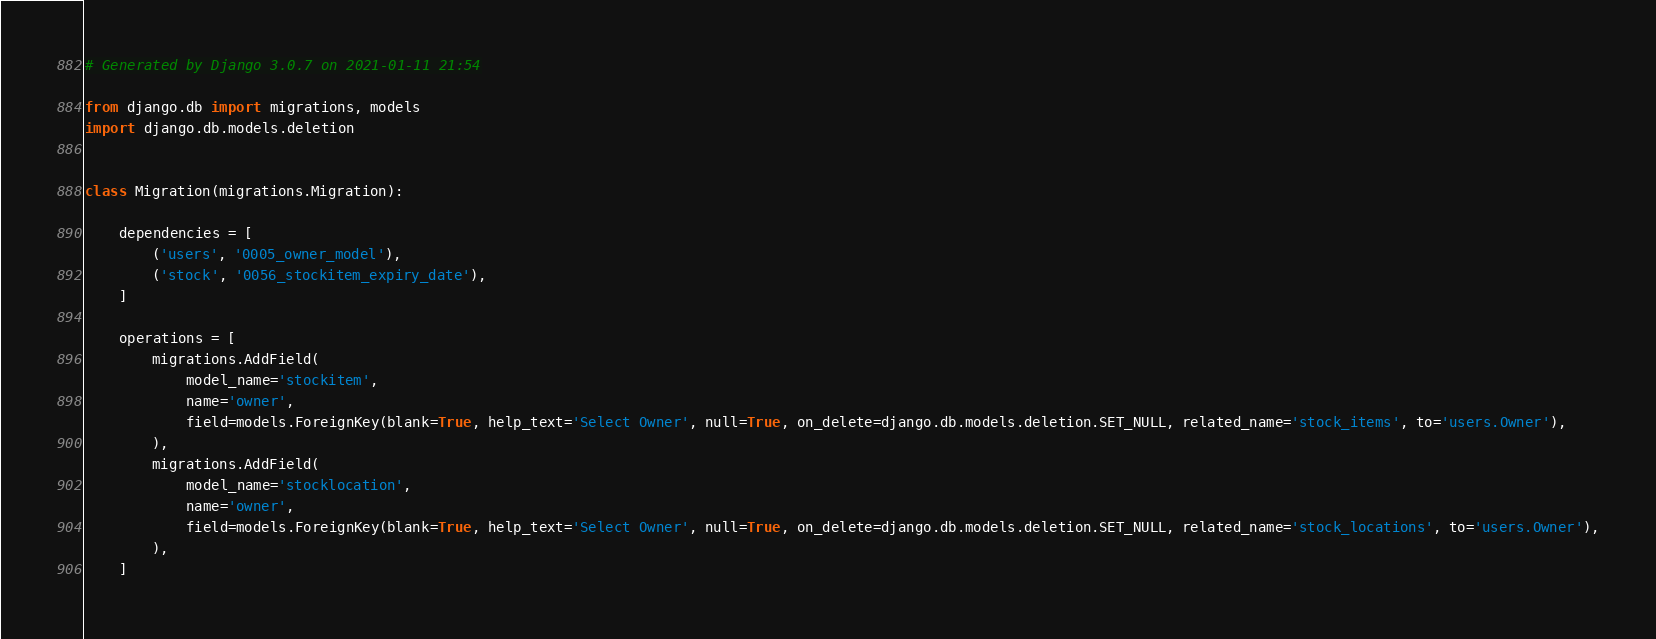Convert code to text. <code><loc_0><loc_0><loc_500><loc_500><_Python_># Generated by Django 3.0.7 on 2021-01-11 21:54

from django.db import migrations, models
import django.db.models.deletion


class Migration(migrations.Migration):

    dependencies = [
        ('users', '0005_owner_model'),
        ('stock', '0056_stockitem_expiry_date'),
    ]

    operations = [
        migrations.AddField(
            model_name='stockitem',
            name='owner',
            field=models.ForeignKey(blank=True, help_text='Select Owner', null=True, on_delete=django.db.models.deletion.SET_NULL, related_name='stock_items', to='users.Owner'),
        ),
        migrations.AddField(
            model_name='stocklocation',
            name='owner',
            field=models.ForeignKey(blank=True, help_text='Select Owner', null=True, on_delete=django.db.models.deletion.SET_NULL, related_name='stock_locations', to='users.Owner'),
        ),
    ]
</code> 